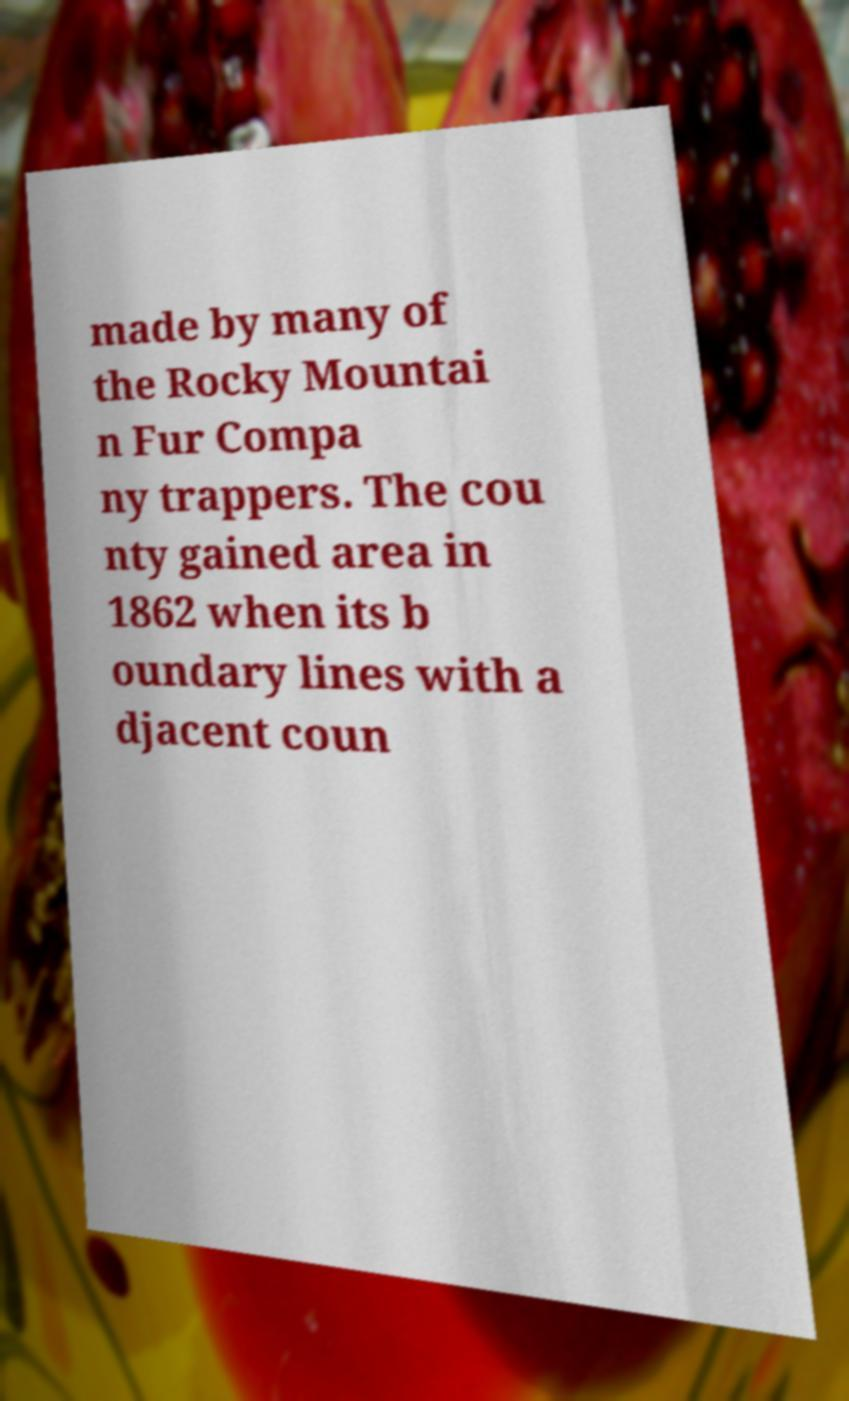Can you read and provide the text displayed in the image?This photo seems to have some interesting text. Can you extract and type it out for me? made by many of the Rocky Mountai n Fur Compa ny trappers. The cou nty gained area in 1862 when its b oundary lines with a djacent coun 